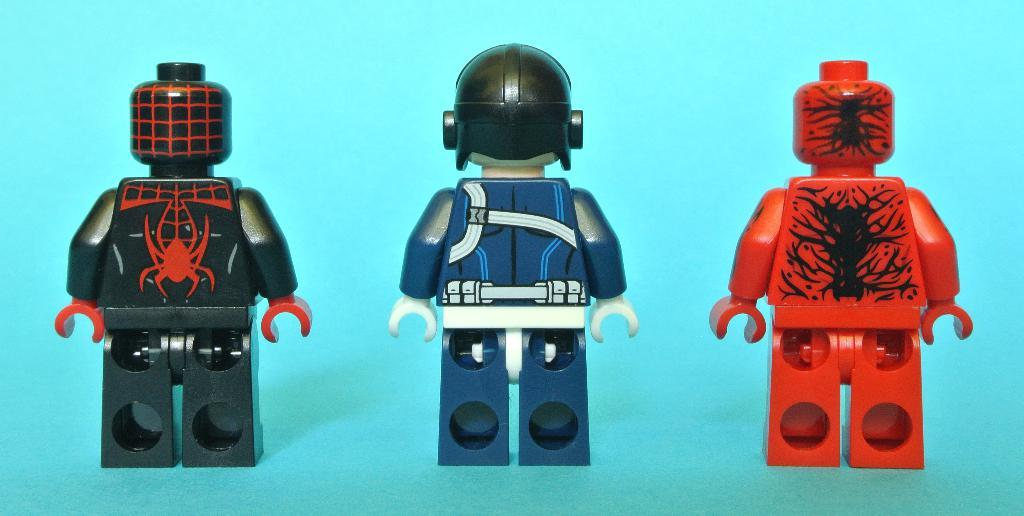What type of toys are featured in the image? There are Lego figurines or characters in the image. Can you describe the appearance of the Lego figures? The Lego figures may have various designs and colors, depending on the specific characters or themes represented. What might the Lego figures be doing in the image? The Lego figures may be engaged in various activities or poses, such as standing, sitting, or interacting with each other. What time of day is depicted in the image, and how does the rake play a role in the scene? The time of day is not mentioned in the image, and there is no rake present in the image. 